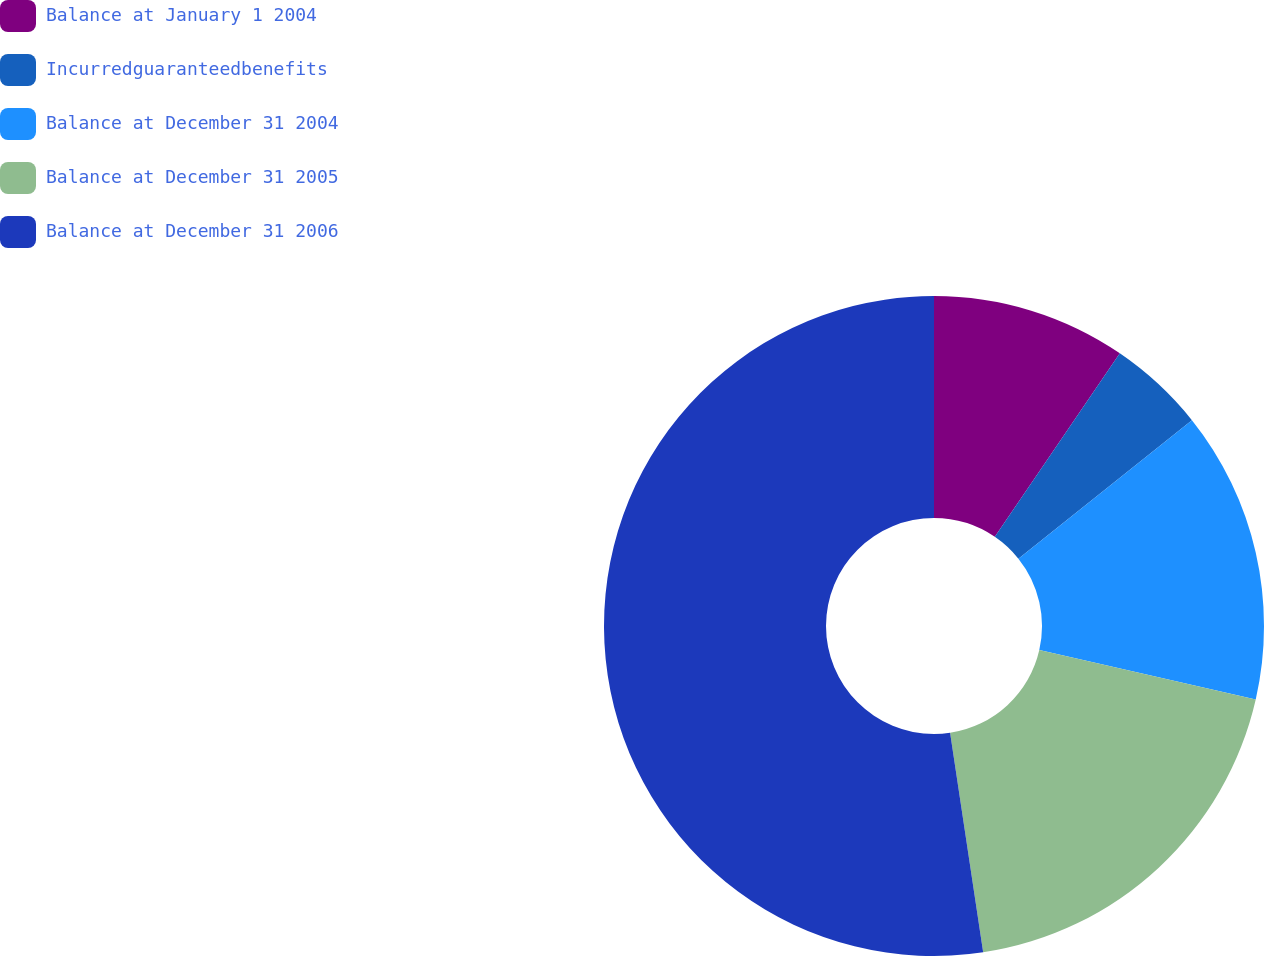Convert chart to OTSL. <chart><loc_0><loc_0><loc_500><loc_500><pie_chart><fcel>Balance at January 1 2004<fcel>Incurredguaranteedbenefits<fcel>Balance at December 31 2004<fcel>Balance at December 31 2005<fcel>Balance at December 31 2006<nl><fcel>9.52%<fcel>4.76%<fcel>14.29%<fcel>19.05%<fcel>52.38%<nl></chart> 